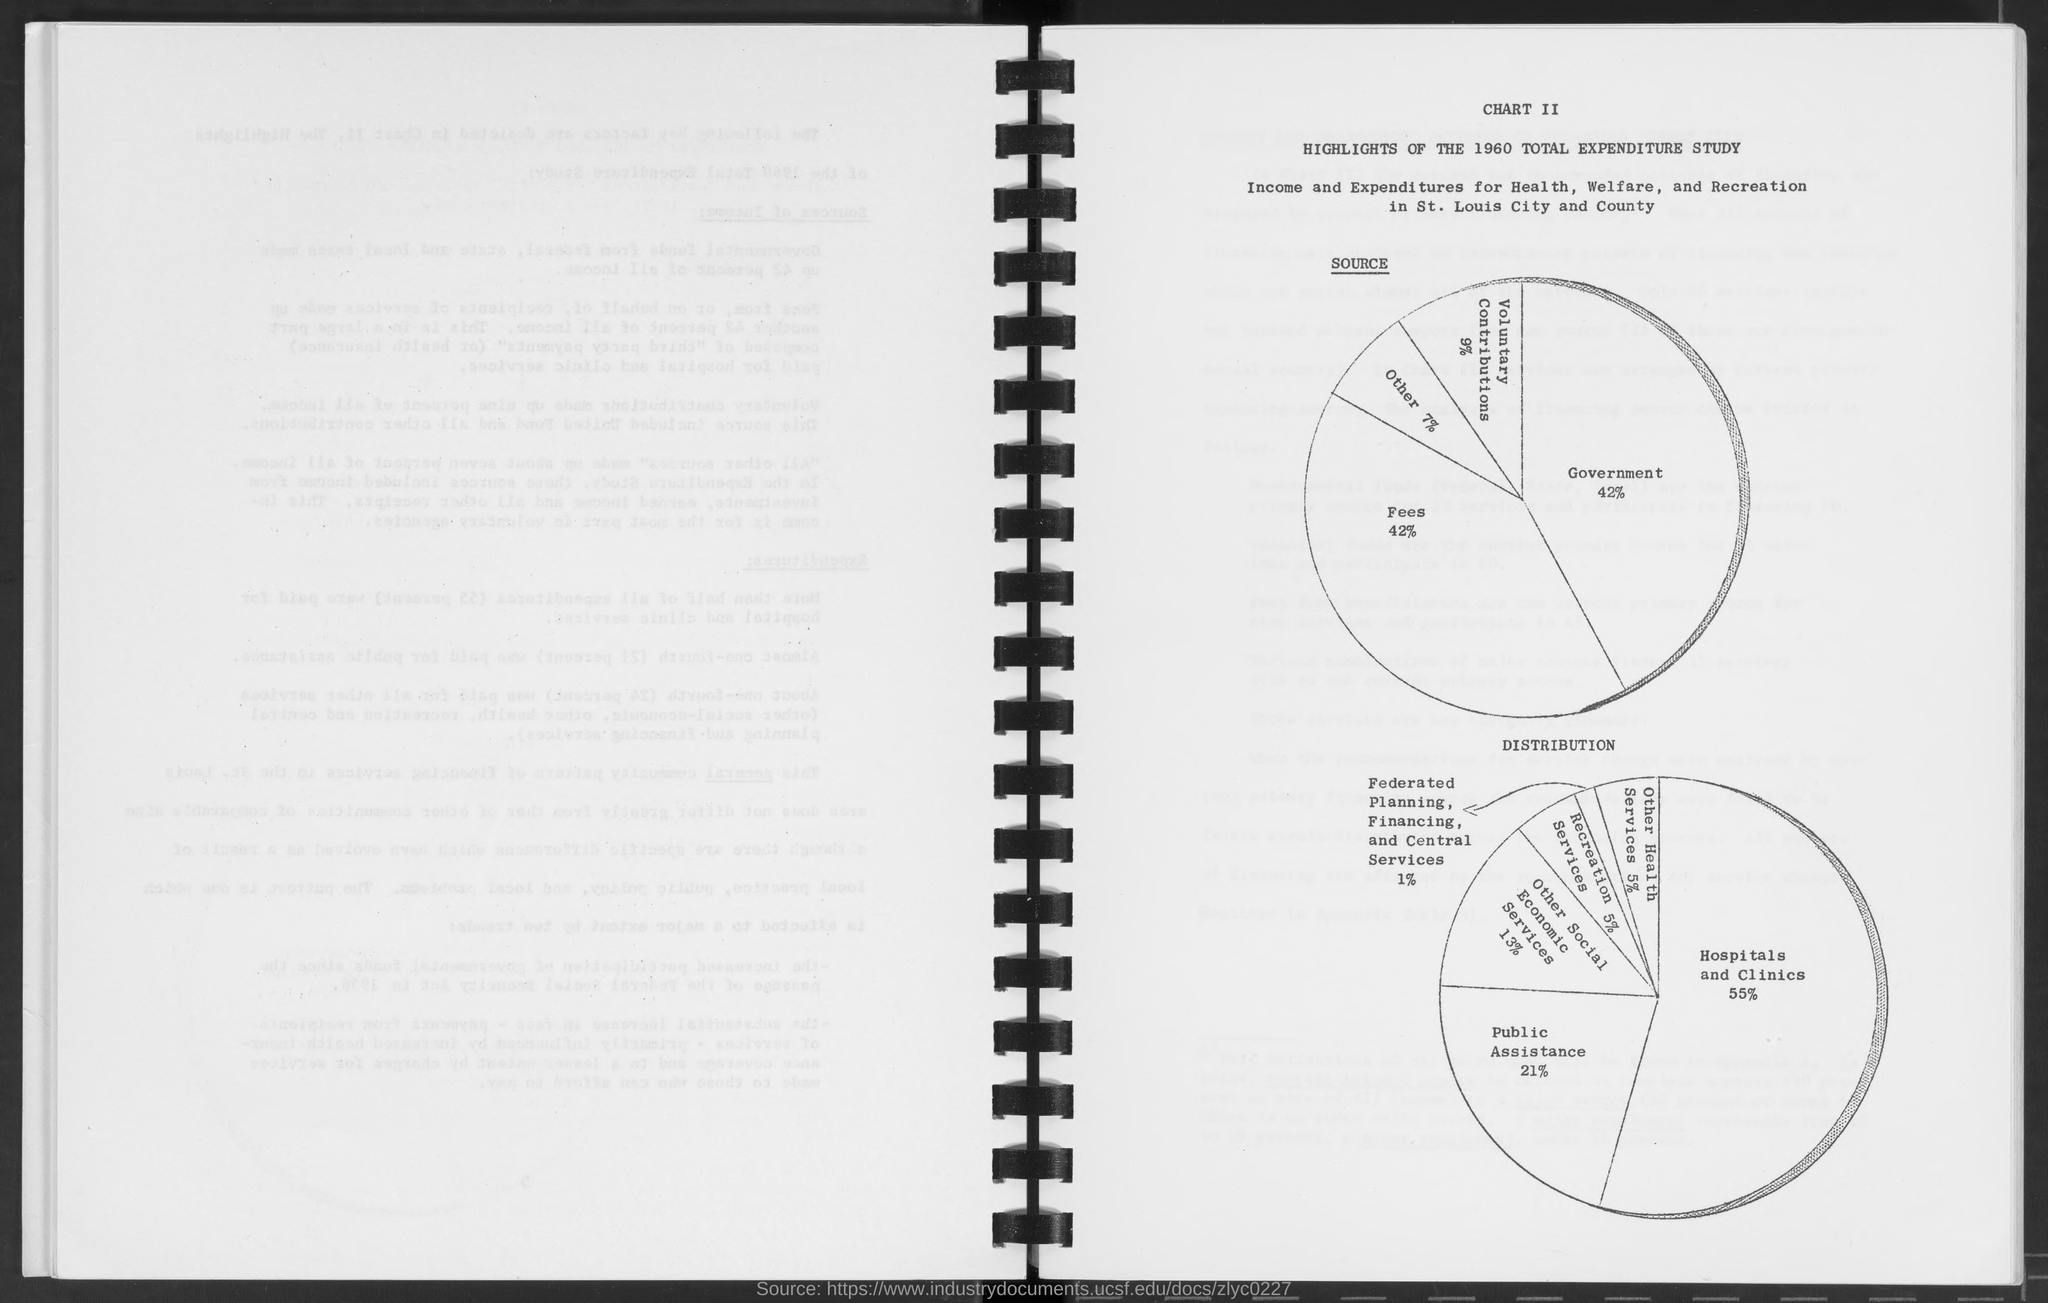Can you provide a breakdown of the distribution for expenditures? Certainly, the distribution pie chart for expenditures highlights that Hospitals and clinics receive the largest portion of 55%, followed by Public Assistance at 21%, and Federated Planning, Financing, and Central Services at 1%. Services other than hospitals account for the remaining 23%. 